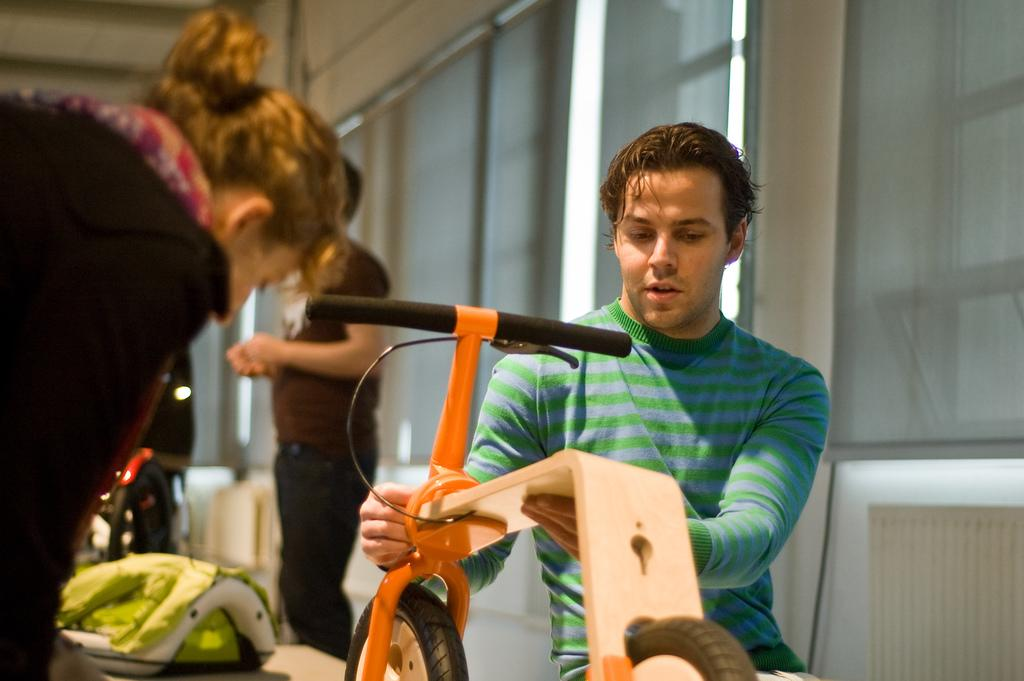How many people are in the image? There are people in the image, but the exact number is not specified. What is the person holding in their hands? One person is holding an object in their hands, but the specific object is not mentioned. What can be seen in the background of the image? There are windows, window blinds, and other objects visible in the background of the image. How much money is being exchanged between the people in the image? There is no mention of money or any exchange of money in the image. What type of cheese is visible on the windowsill in the image? There is no cheese visible in the image. 